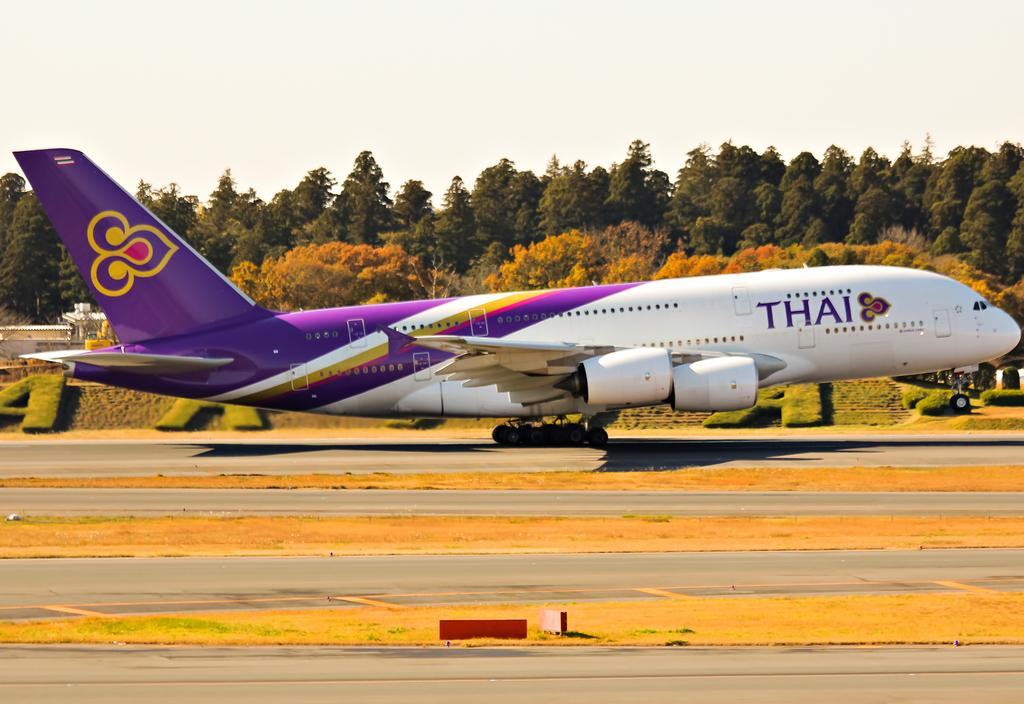Provide a one-sentence caption for the provided image. A purple and white airplane has the word Thai on the front. 